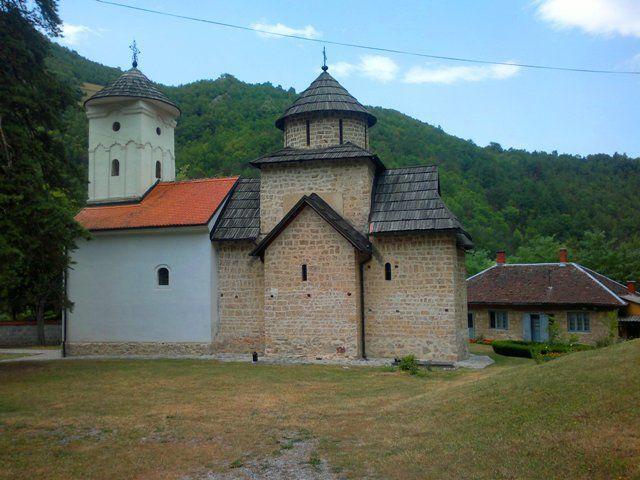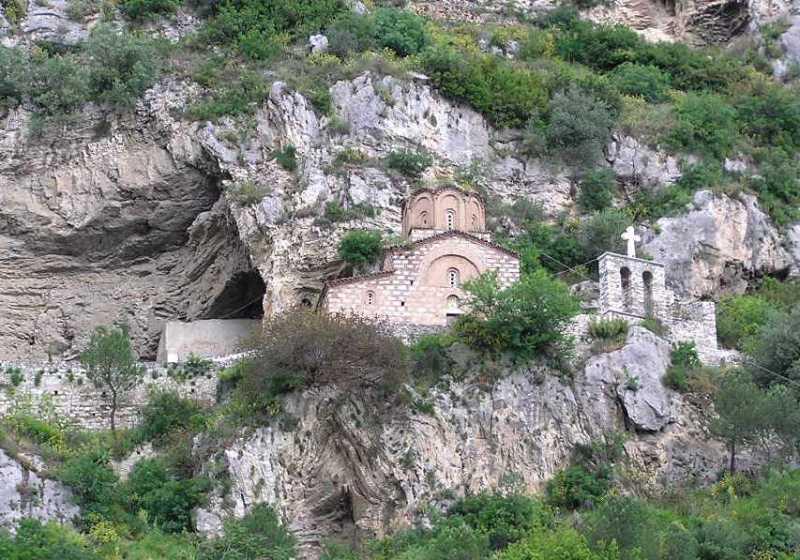The first image is the image on the left, the second image is the image on the right. Examine the images to the left and right. Is the description "There's a dirt path through the grass in the left image." accurate? Answer yes or no. No. The first image is the image on the left, the second image is the image on the right. Analyze the images presented: Is the assertion "One building is beige stone with arch elements and a landscaped lawn that includes shrubs." valid? Answer yes or no. No. 